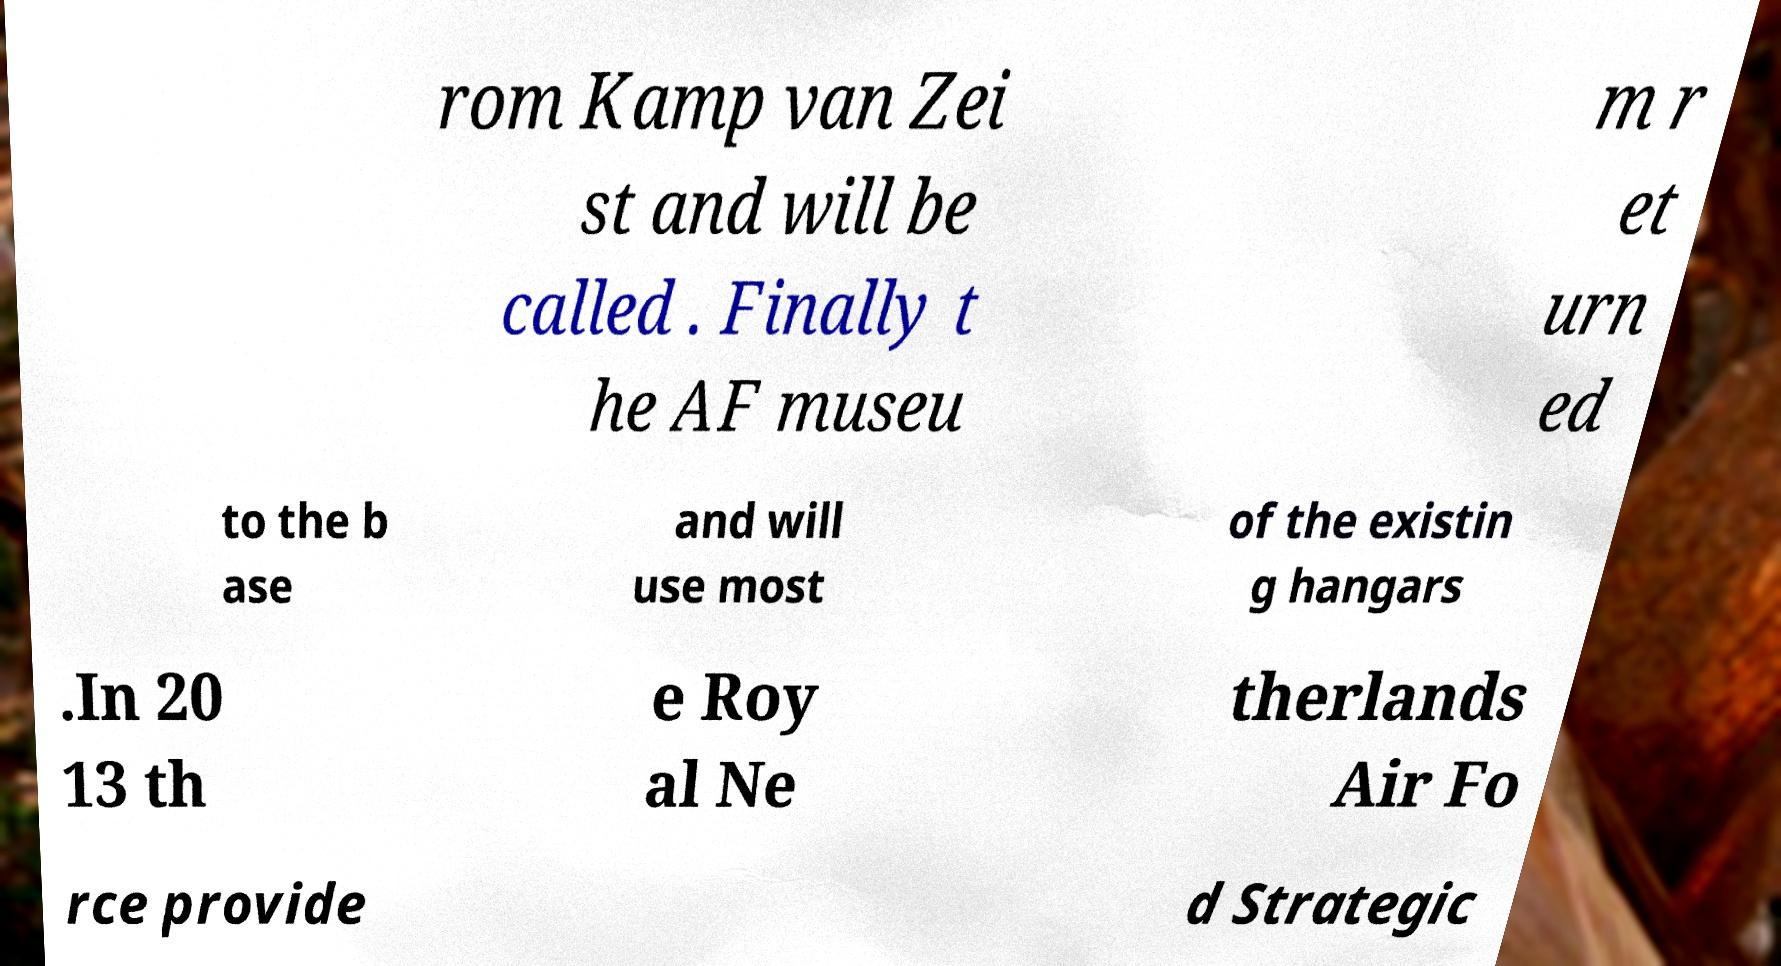Could you assist in decoding the text presented in this image and type it out clearly? rom Kamp van Zei st and will be called . Finally t he AF museu m r et urn ed to the b ase and will use most of the existin g hangars .In 20 13 th e Roy al Ne therlands Air Fo rce provide d Strategic 